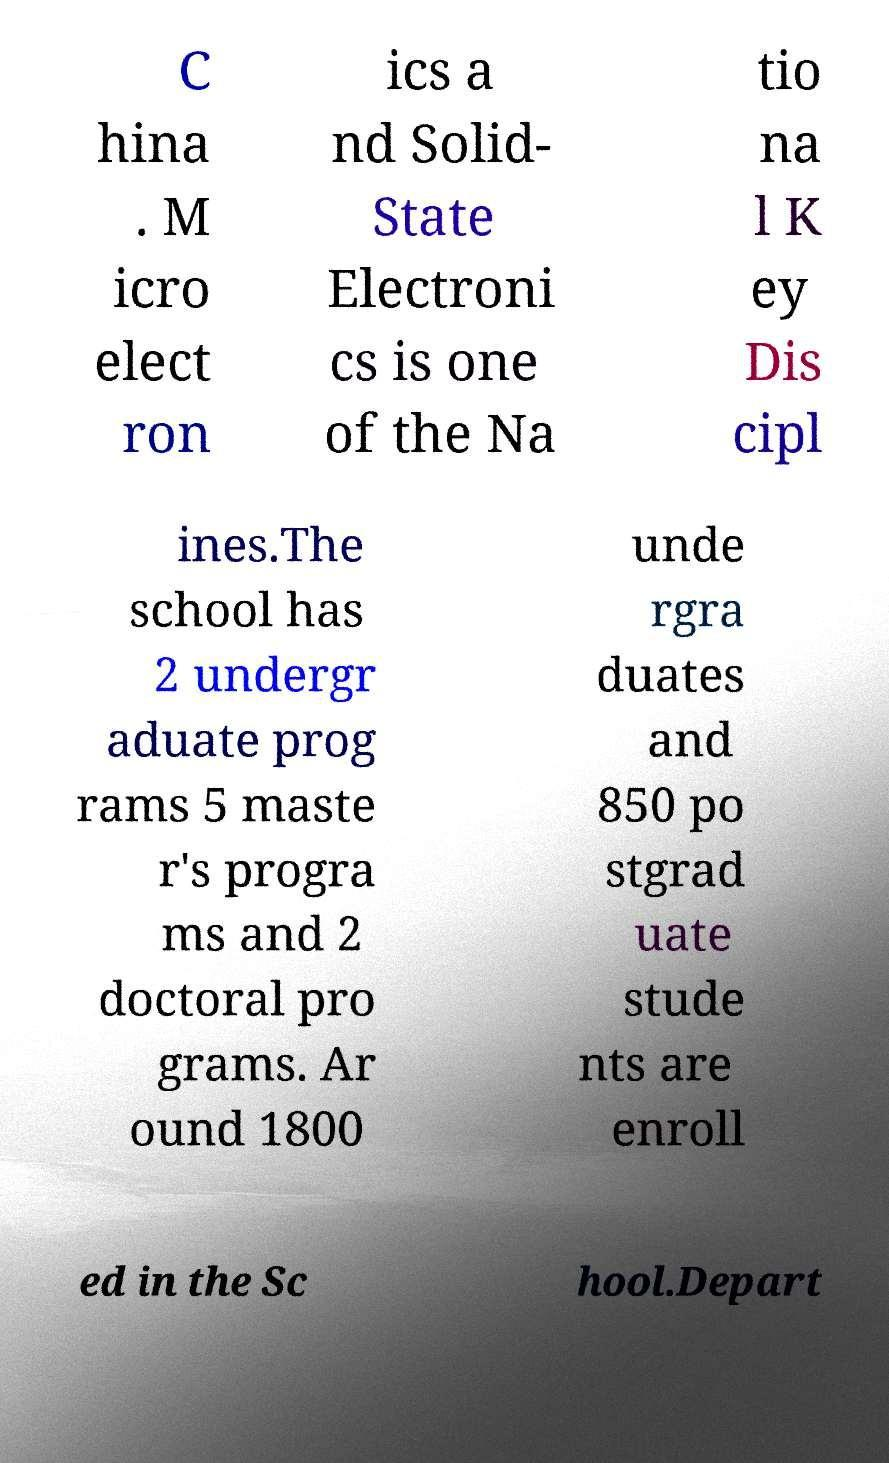Could you assist in decoding the text presented in this image and type it out clearly? C hina . M icro elect ron ics a nd Solid- State Electroni cs is one of the Na tio na l K ey Dis cipl ines.The school has 2 undergr aduate prog rams 5 maste r's progra ms and 2 doctoral pro grams. Ar ound 1800 unde rgra duates and 850 po stgrad uate stude nts are enroll ed in the Sc hool.Depart 